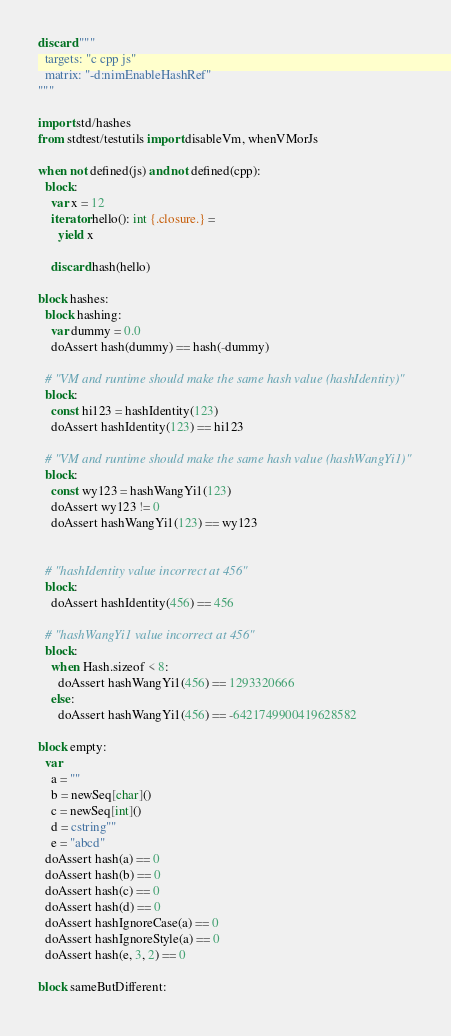Convert code to text. <code><loc_0><loc_0><loc_500><loc_500><_Nim_>discard """
  targets: "c cpp js"
  matrix: "-d:nimEnableHashRef"
"""

import std/hashes
from stdtest/testutils import disableVm, whenVMorJs

when not defined(js) and not defined(cpp):
  block:
    var x = 12
    iterator hello(): int {.closure.} =
      yield x

    discard hash(hello)

block hashes:
  block hashing:
    var dummy = 0.0
    doAssert hash(dummy) == hash(-dummy)

  # "VM and runtime should make the same hash value (hashIdentity)"
  block:
    const hi123 = hashIdentity(123)
    doAssert hashIdentity(123) == hi123

  # "VM and runtime should make the same hash value (hashWangYi1)"
  block:
    const wy123 = hashWangYi1(123)
    doAssert wy123 != 0
    doAssert hashWangYi1(123) == wy123


  # "hashIdentity value incorrect at 456"
  block:
    doAssert hashIdentity(456) == 456

  # "hashWangYi1 value incorrect at 456"
  block:
    when Hash.sizeof < 8:
      doAssert hashWangYi1(456) == 1293320666
    else:
      doAssert hashWangYi1(456) == -6421749900419628582

block empty:
  var
    a = ""
    b = newSeq[char]()
    c = newSeq[int]()
    d = cstring""
    e = "abcd"
  doAssert hash(a) == 0
  doAssert hash(b) == 0
  doAssert hash(c) == 0
  doAssert hash(d) == 0
  doAssert hashIgnoreCase(a) == 0
  doAssert hashIgnoreStyle(a) == 0
  doAssert hash(e, 3, 2) == 0

block sameButDifferent:</code> 